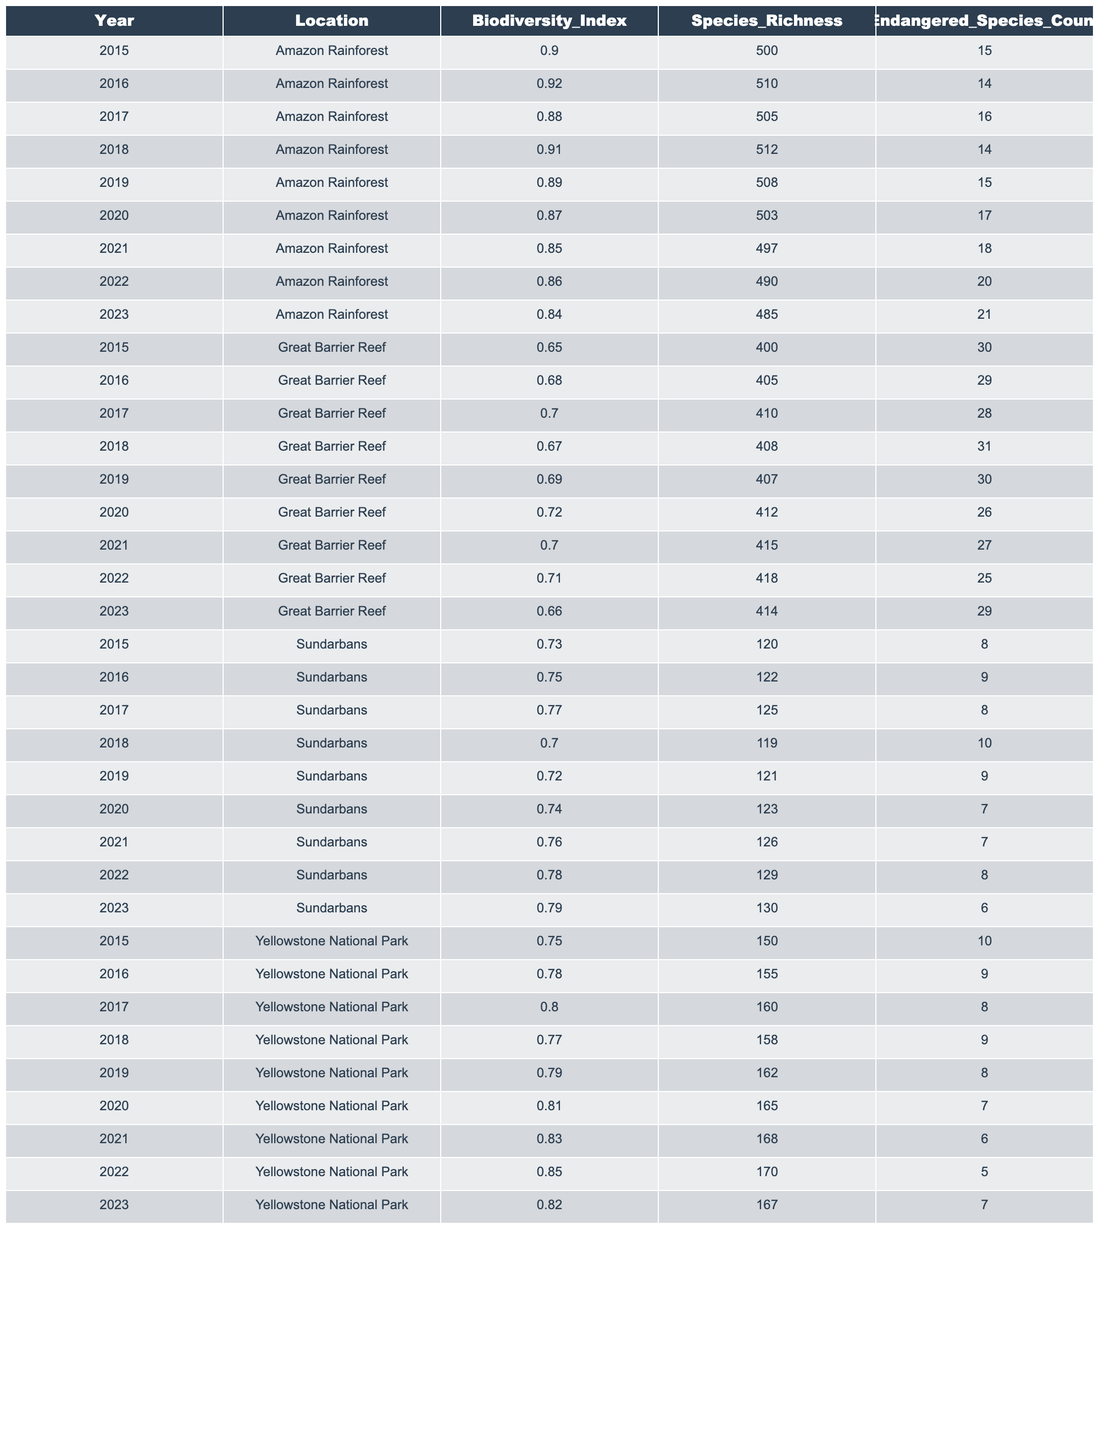What was the highest Biodiversity Index recorded in Yellowstone National Park? Looking at the table for Yellowstone National Park, the Biodiversity Index values over the years range from 0.75 to 0.85. The highest value is 0.85 recorded in 2022.
Answer: 0.85 What year did the Great Barrier Reef have the lowest Biodiversity Index? Checking the values for the Great Barrier Reef, the Biodiversity Index values are 0.65 in 2015, which is the lowest year recorded.
Answer: 2015 What is the total count of endangered species across all years in the Amazon Rainforest? Adding the endangered species counts from all years in the Amazon Rainforest gives us (15 + 14 + 16 + 14 + 15 + 17 + 18 + 20 + 21) = 150.
Answer: 150 Has the species richness in Sundarbans increased each year? Reviewing the species richness values shows a trend: 120 in 2015, increasing to 130 in 2023 with some variations; it does not consistently increase yearly. Thus, the statement is false.
Answer: No What is the average Biodiversity Index for the Great Barrier Reef over the years? Calculating the average involves adding all the Biodiversity Index values (0.65 + 0.68 + 0.70 + 0.67 + 0.69 + 0.72 + 0.70 + 0.71 + 0.66) = 6.44, and dividing by the number of years (9), which gives 6.44/9 ≈ 0.716.
Answer: 0.716 In which year did the Amazon Rainforest see the highest species richness? By examining the species richness values, 510 in 2016 is the highest compared to others, confirming that this year had the highest species richness.
Answer: 2016 How many endangered species were recorded in Yellowstone National Park in 2019? Looking at the data for Yellowstone in 2019, the endangered species count is 8.
Answer: 8 What was the change in the Biodiversity Index from 2018 to 2022 in Yellowstone National Park? The Biodiversity Index in 2018 is 0.77 and in 2022 it is 0.85. The change is 0.85 - 0.77 = 0.08, indicating an increase.
Answer: 0.08 Which location had the highest Biodiversity Index in 2023? Comparing the Biodiversity Index values for 2023, Yellowstone National Park has 0.82, the Great Barrier Reef has 0.66, and Amazon Rainforest has 0.84. Hence, the Amazon Rainforest had the highest Index.
Answer: Amazon Rainforest How many more species were present in Amazon Rainforest compared to Sundarbans in 2023? For 2023, the Amazon Rainforest has 485 species and Sundarbans has 130 species; thus, the difference is 485 - 130 = 355 species.
Answer: 355 What trend can be observed in the endangered species count in Great Barrier Reef from 2015 to 2023? Observing the endangered species from 2015 (30) to 2023 (29), there has been a general decrease in numbers across the years, indicating a downward trend.
Answer: Downward trend 